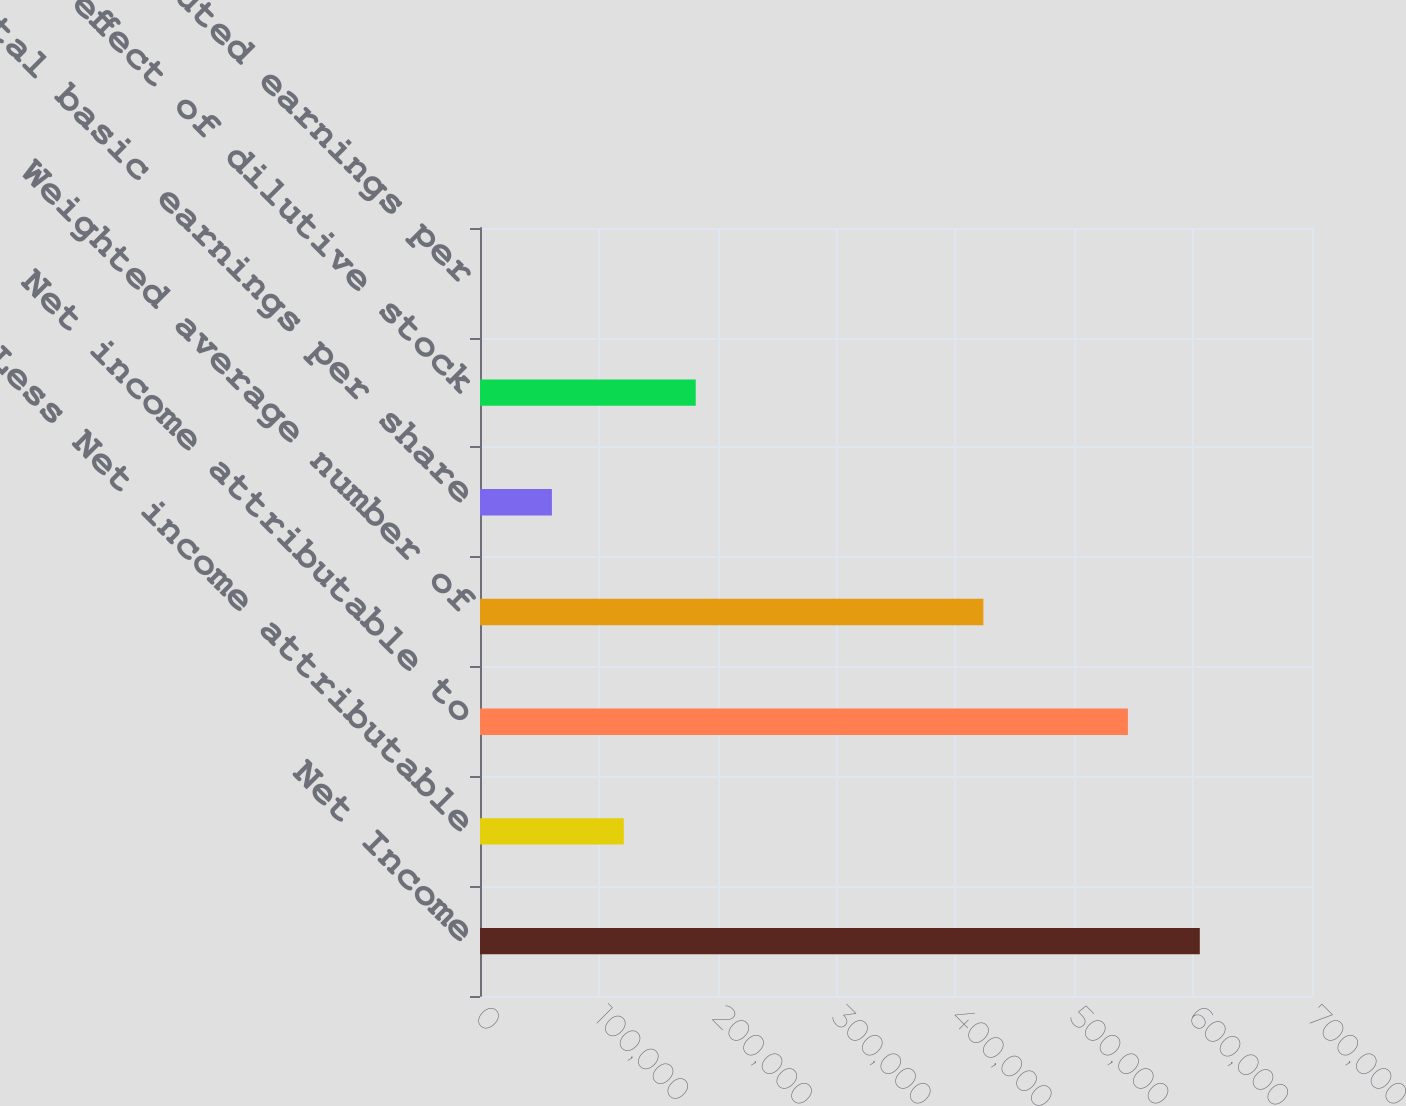Convert chart to OTSL. <chart><loc_0><loc_0><loc_500><loc_500><bar_chart><fcel>Net Income<fcel>Less Net income attributable<fcel>Net income attributable to<fcel>Weighted average number of<fcel>Total basic earnings per share<fcel>Net effect of dilutive stock<fcel>Total diluted earnings per<nl><fcel>605606<fcel>121004<fcel>545107<fcel>423499<fcel>60504.5<fcel>181503<fcel>5.42<nl></chart> 